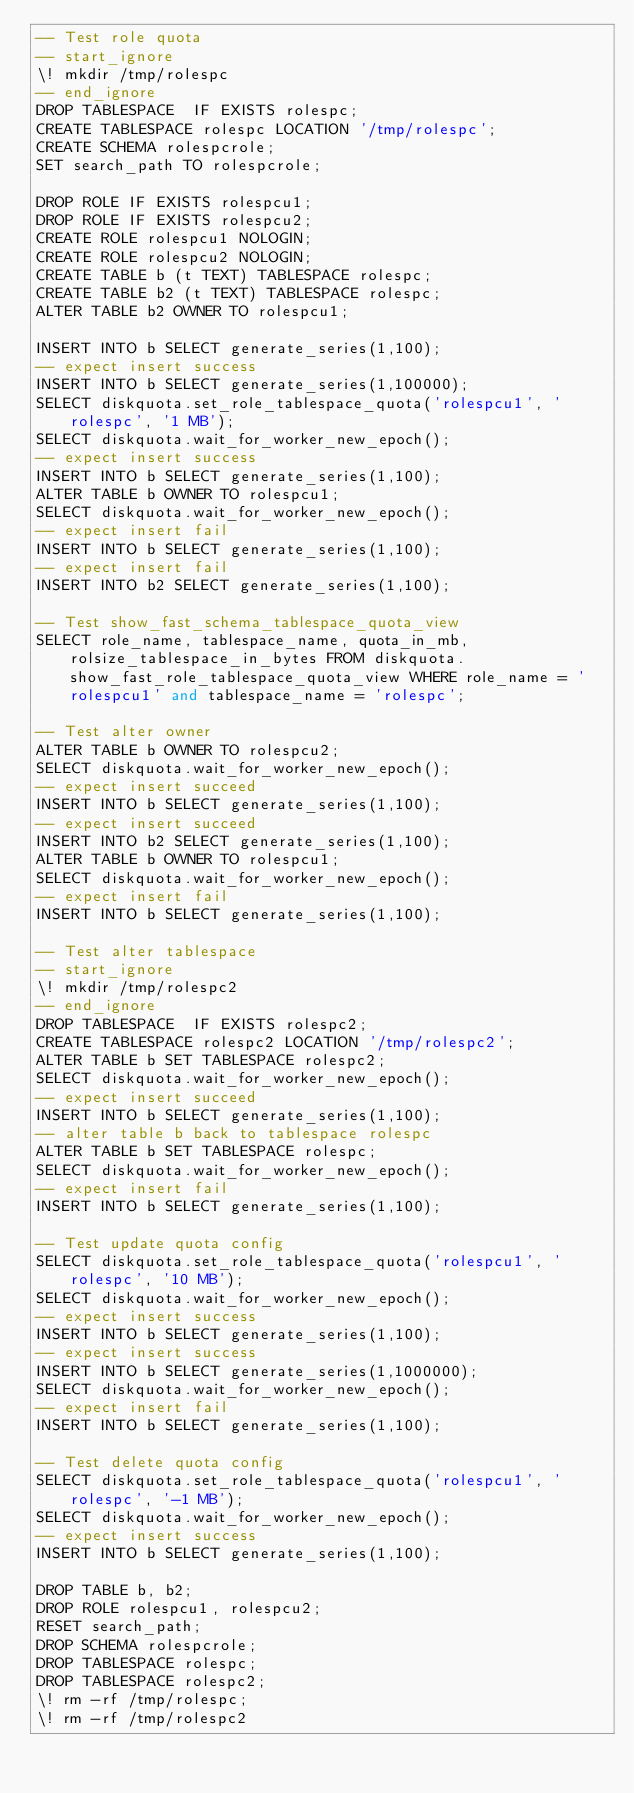Convert code to text. <code><loc_0><loc_0><loc_500><loc_500><_SQL_>-- Test role quota
-- start_ignore
\! mkdir /tmp/rolespc
-- end_ignore
DROP TABLESPACE  IF EXISTS rolespc;
CREATE TABLESPACE rolespc LOCATION '/tmp/rolespc';
CREATE SCHEMA rolespcrole;
SET search_path TO rolespcrole;

DROP ROLE IF EXISTS rolespcu1;
DROP ROLE IF EXISTS rolespcu2;
CREATE ROLE rolespcu1 NOLOGIN;
CREATE ROLE rolespcu2 NOLOGIN;
CREATE TABLE b (t TEXT) TABLESPACE rolespc;
CREATE TABLE b2 (t TEXT) TABLESPACE rolespc;
ALTER TABLE b2 OWNER TO rolespcu1;

INSERT INTO b SELECT generate_series(1,100);
-- expect insert success
INSERT INTO b SELECT generate_series(1,100000);
SELECT diskquota.set_role_tablespace_quota('rolespcu1', 'rolespc', '1 MB');
SELECT diskquota.wait_for_worker_new_epoch();
-- expect insert success
INSERT INTO b SELECT generate_series(1,100);
ALTER TABLE b OWNER TO rolespcu1;
SELECT diskquota.wait_for_worker_new_epoch();
-- expect insert fail
INSERT INTO b SELECT generate_series(1,100);
-- expect insert fail
INSERT INTO b2 SELECT generate_series(1,100);

-- Test show_fast_schema_tablespace_quota_view
SELECT role_name, tablespace_name, quota_in_mb, rolsize_tablespace_in_bytes FROM diskquota.show_fast_role_tablespace_quota_view WHERE role_name = 'rolespcu1' and tablespace_name = 'rolespc';

-- Test alter owner
ALTER TABLE b OWNER TO rolespcu2;
SELECT diskquota.wait_for_worker_new_epoch();
-- expect insert succeed
INSERT INTO b SELECT generate_series(1,100);
-- expect insert succeed
INSERT INTO b2 SELECT generate_series(1,100);
ALTER TABLE b OWNER TO rolespcu1;
SELECT diskquota.wait_for_worker_new_epoch();
-- expect insert fail
INSERT INTO b SELECT generate_series(1,100);

-- Test alter tablespace
-- start_ignore
\! mkdir /tmp/rolespc2
-- end_ignore
DROP TABLESPACE  IF EXISTS rolespc2;
CREATE TABLESPACE rolespc2 LOCATION '/tmp/rolespc2';
ALTER TABLE b SET TABLESPACE rolespc2;
SELECT diskquota.wait_for_worker_new_epoch();
-- expect insert succeed
INSERT INTO b SELECT generate_series(1,100);
-- alter table b back to tablespace rolespc
ALTER TABLE b SET TABLESPACE rolespc;
SELECT diskquota.wait_for_worker_new_epoch();
-- expect insert fail
INSERT INTO b SELECT generate_series(1,100);

-- Test update quota config
SELECT diskquota.set_role_tablespace_quota('rolespcu1', 'rolespc', '10 MB');
SELECT diskquota.wait_for_worker_new_epoch();
-- expect insert success
INSERT INTO b SELECT generate_series(1,100);
-- expect insert success
INSERT INTO b SELECT generate_series(1,1000000);
SELECT diskquota.wait_for_worker_new_epoch();
-- expect insert fail
INSERT INTO b SELECT generate_series(1,100);

-- Test delete quota config
SELECT diskquota.set_role_tablespace_quota('rolespcu1', 'rolespc', '-1 MB');
SELECT diskquota.wait_for_worker_new_epoch();
-- expect insert success
INSERT INTO b SELECT generate_series(1,100);

DROP TABLE b, b2;
DROP ROLE rolespcu1, rolespcu2;
RESET search_path;
DROP SCHEMA rolespcrole;
DROP TABLESPACE rolespc;
DROP TABLESPACE rolespc2;
\! rm -rf /tmp/rolespc;
\! rm -rf /tmp/rolespc2
</code> 